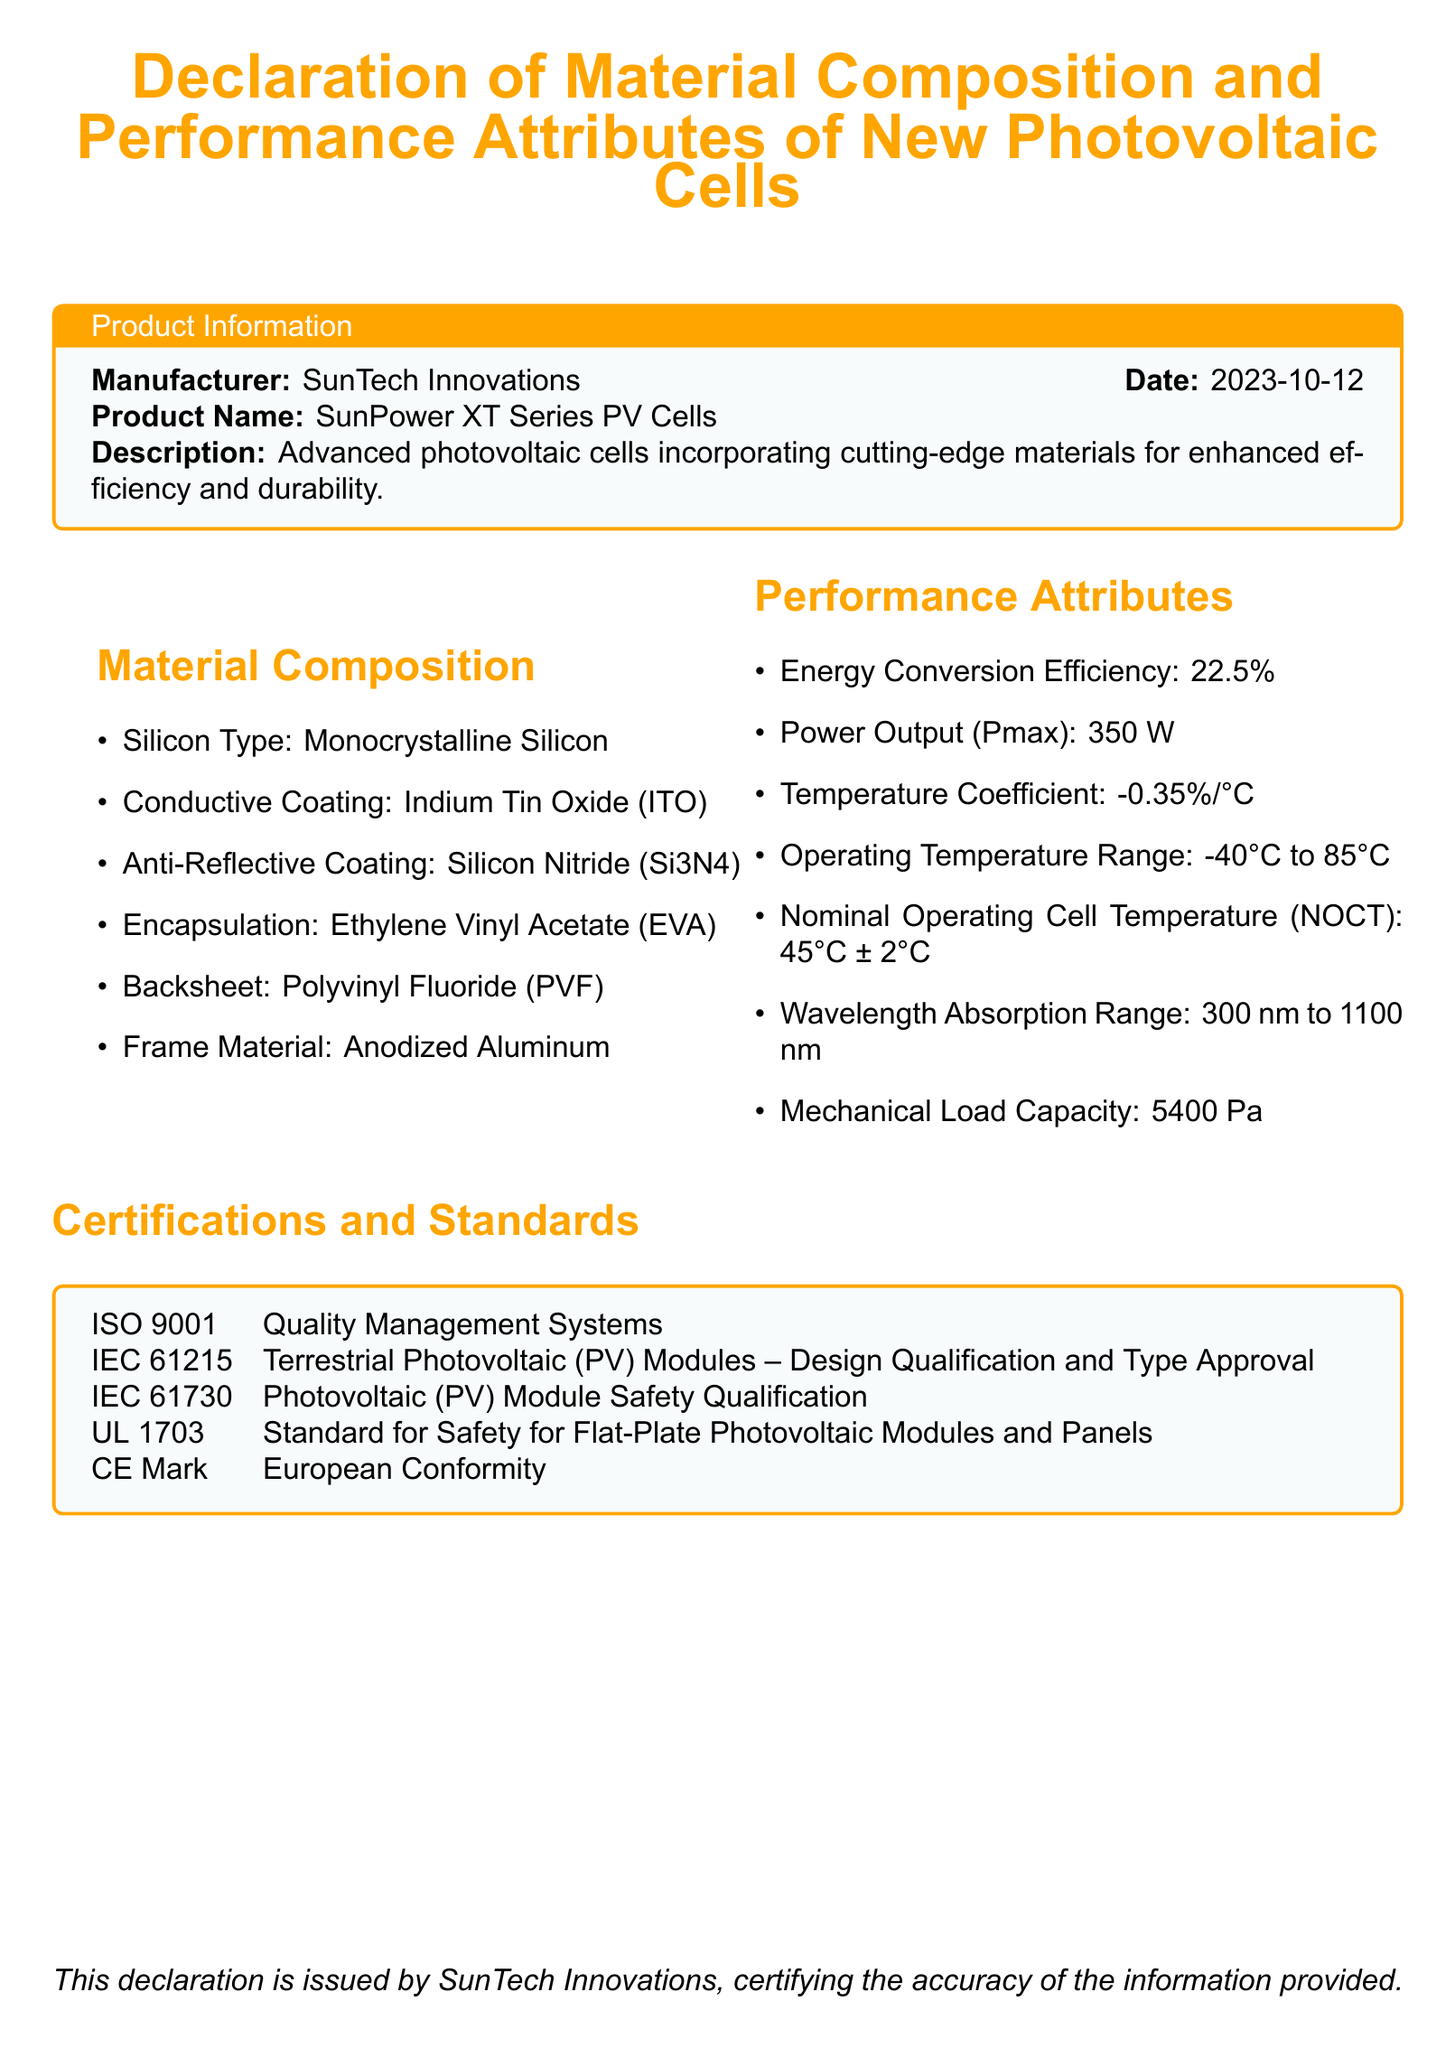What is the manufacturer of the photovoltaic cells? The manufacturer is specified in the Product Information section of the document.
Answer: SunTech Innovations What is the date of the declaration? The date is provided in the Product Information section along with the manufacturer.
Answer: 2023-10-12 What is the energy conversion efficiency of the cells? The energy conversion efficiency is listed under Performance Attributes.
Answer: 22.5% What material is used for the frame of the photovoltaic cells? The frame material is mentioned in the Material Composition section.
Answer: Anodized Aluminum What is the power output (Pmax) of the SunPower XT Series? The power output is specified under Performance Attributes.
Answer: 350 W What is the wavelength absorption range of the photovoltaic cells? The wavelength absorption range is detailed in the Performance Attributes section.
Answer: 300 nm to 1100 nm How many certifications are listed in the document? The number of certifications can be counted from the Certifications and Standards section.
Answer: 5 What is the mechanical load capacity of the cells? The mechanical load capacity is found in the Performance Attributes section.
Answer: 5400 Pa Which standard is associated with safety for flat-plate photovoltaic modules? The specific standard is named under Certifications and Standards.
Answer: UL 1703 